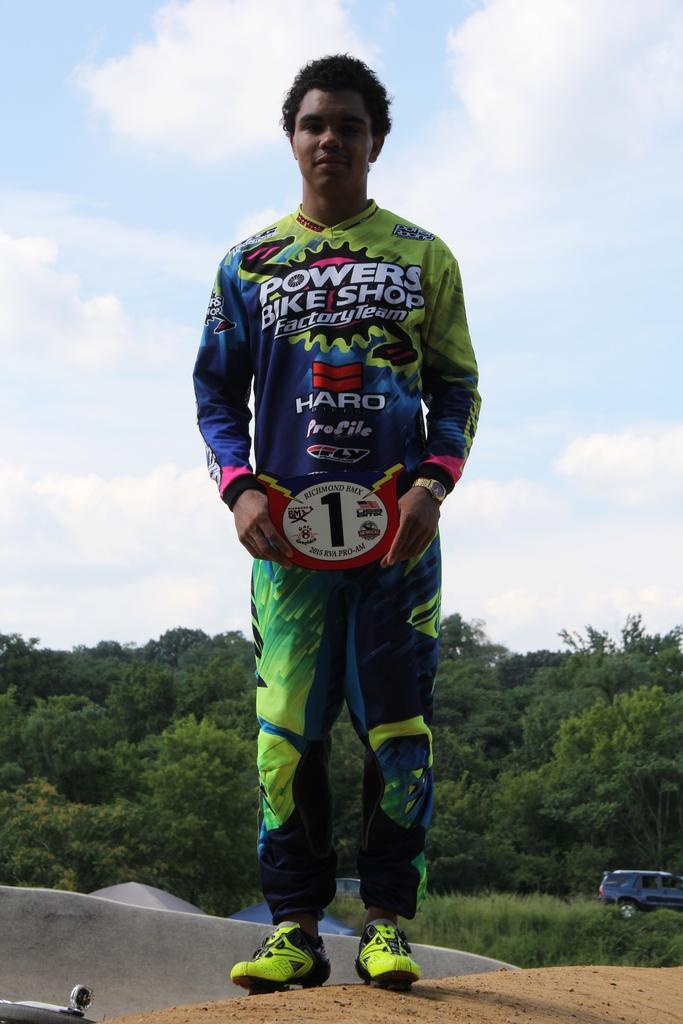<image>
Offer a succinct explanation of the picture presented. A young man wears colorful clothes sponsored by Powers Bike Shop. 